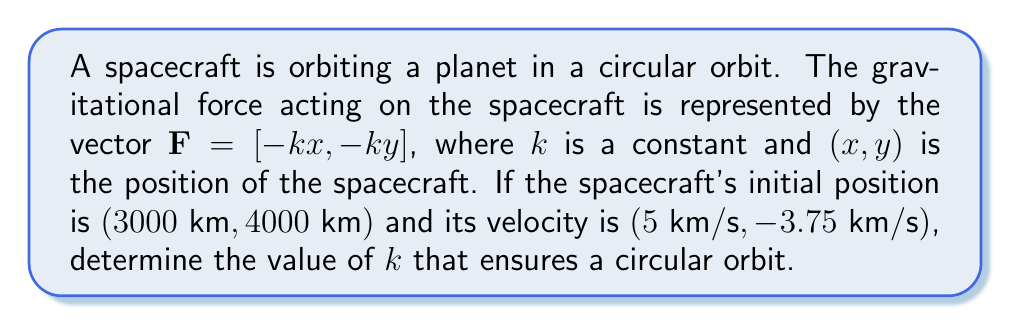Give your solution to this math problem. Let's approach this step-by-step:

1) For a circular orbit, the centripetal force must equal the gravitational force. The centripetal force is given by $F_c = \frac{mv^2}{r}$, where $m$ is the mass of the spacecraft, $v$ is its velocity, and $r$ is the radius of the orbit.

2) The gravitational force magnitude is $F_g = k\sqrt{x^2 + y^2}$.

3) For a circular orbit, these forces must be equal:

   $$\frac{mv^2}{r} = k\sqrt{x^2 + y^2}$$

4) The radius of the orbit can be calculated from the initial position:
   
   $$r = \sqrt{3000^2 + 4000^2} = 5000\text{ km}$$

5) The velocity can be calculated from the given components:
   
   $$v = \sqrt{5^2 + (-3.75)^2} = 6.25\text{ km/s}$$

6) Substituting these into the force equation:

   $$\frac{m(6.25)^2}{5000} = k(5000)$$

7) The mass $m$ cancels out:

   $$\frac{39.0625}{5000} = k$$

8) Solving for $k$:

   $$k = 0.0078125\text{ s}^{-2}$$
Answer: $k = 0.0078125\text{ s}^{-2}$ 